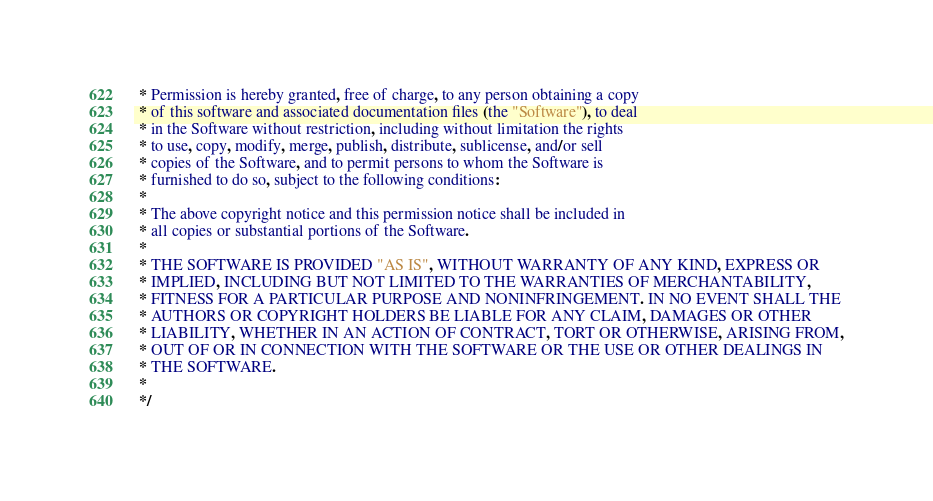Convert code to text. <code><loc_0><loc_0><loc_500><loc_500><_CSS_> * Permission is hereby granted, free of charge, to any person obtaining a copy
 * of this software and associated documentation files (the "Software"), to deal
 * in the Software without restriction, including without limitation the rights
 * to use, copy, modify, merge, publish, distribute, sublicense, and/or sell
 * copies of the Software, and to permit persons to whom the Software is
 * furnished to do so, subject to the following conditions:
 *
 * The above copyright notice and this permission notice shall be included in
 * all copies or substantial portions of the Software.
 *
 * THE SOFTWARE IS PROVIDED "AS IS", WITHOUT WARRANTY OF ANY KIND, EXPRESS OR
 * IMPLIED, INCLUDING BUT NOT LIMITED TO THE WARRANTIES OF MERCHANTABILITY,
 * FITNESS FOR A PARTICULAR PURPOSE AND NONINFRINGEMENT. IN NO EVENT SHALL THE
 * AUTHORS OR COPYRIGHT HOLDERS BE LIABLE FOR ANY CLAIM, DAMAGES OR OTHER
 * LIABILITY, WHETHER IN AN ACTION OF CONTRACT, TORT OR OTHERWISE, ARISING FROM,
 * OUT OF OR IN CONNECTION WITH THE SOFTWARE OR THE USE OR OTHER DEALINGS IN
 * THE SOFTWARE.
 *
 */</code> 